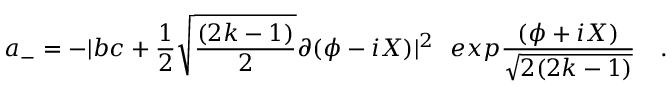<formula> <loc_0><loc_0><loc_500><loc_500>a _ { - } = - | b c + { \frac { 1 } { 2 } } \sqrt { \frac { ( 2 k - 1 ) } { 2 } } \partial ( \phi - i X ) | ^ { 2 e x p { \frac { ( \phi + i X ) } { \sqrt { 2 ( 2 k - 1 ) } } } \quad .</formula> 